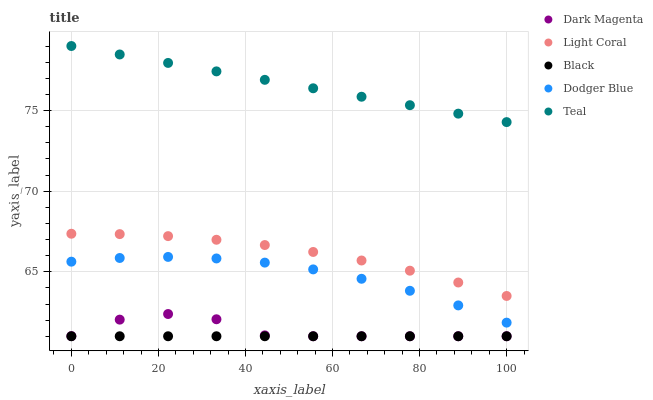Does Black have the minimum area under the curve?
Answer yes or no. Yes. Does Teal have the maximum area under the curve?
Answer yes or no. Yes. Does Dodger Blue have the minimum area under the curve?
Answer yes or no. No. Does Dodger Blue have the maximum area under the curve?
Answer yes or no. No. Is Black the smoothest?
Answer yes or no. Yes. Is Dark Magenta the roughest?
Answer yes or no. Yes. Is Dodger Blue the smoothest?
Answer yes or no. No. Is Dodger Blue the roughest?
Answer yes or no. No. Does Black have the lowest value?
Answer yes or no. Yes. Does Dodger Blue have the lowest value?
Answer yes or no. No. Does Teal have the highest value?
Answer yes or no. Yes. Does Dodger Blue have the highest value?
Answer yes or no. No. Is Dodger Blue less than Teal?
Answer yes or no. Yes. Is Teal greater than Black?
Answer yes or no. Yes. Does Black intersect Dark Magenta?
Answer yes or no. Yes. Is Black less than Dark Magenta?
Answer yes or no. No. Is Black greater than Dark Magenta?
Answer yes or no. No. Does Dodger Blue intersect Teal?
Answer yes or no. No. 